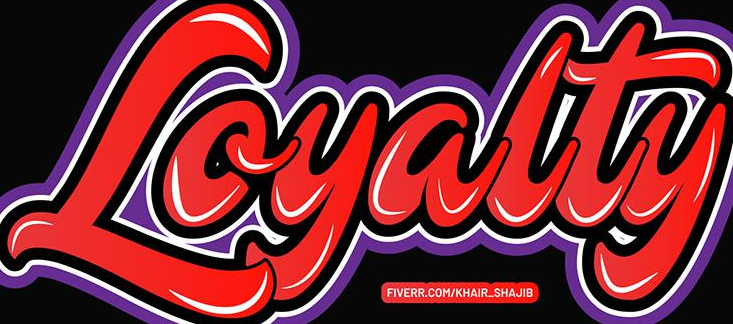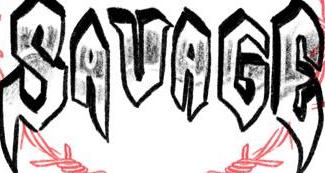Read the text from these images in sequence, separated by a semicolon. Loyalty; SAVAGE 